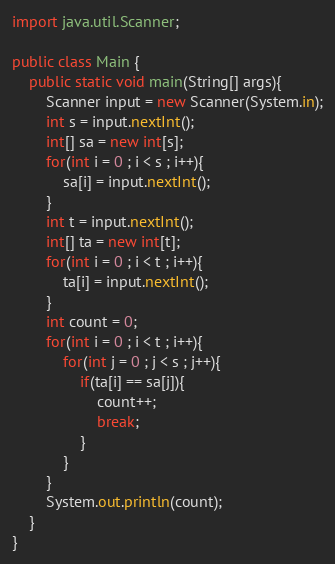Convert code to text. <code><loc_0><loc_0><loc_500><loc_500><_Java_>import java.util.Scanner;

public class Main {
    public static void main(String[] args){
    	Scanner input = new Scanner(System.in);
    	int s = input.nextInt();
    	int[] sa = new int[s];
    	for(int i = 0 ; i < s ; i++){
    		sa[i] = input.nextInt();
    	}
    	int t = input.nextInt();
    	int[] ta = new int[t];
    	for(int i = 0 ; i < t ; i++){
    		ta[i] = input.nextInt();
    	}
    	int count = 0;
    	for(int i = 0 ; i < t ; i++){
    		for(int j = 0 ; j < s ; j++){
    			if(ta[i] == sa[j]){
    				count++;
    				break;
    			}
    		}
    	}
    	System.out.println(count);
    }
}</code> 